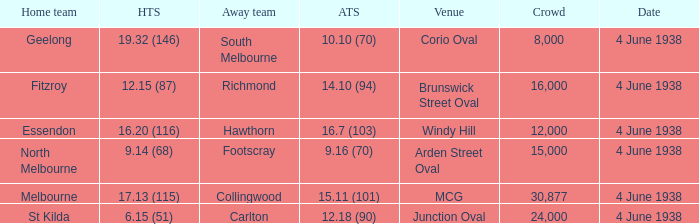What was the score for Geelong? 10.10 (70). 